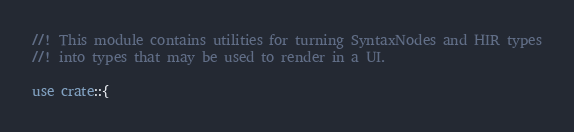<code> <loc_0><loc_0><loc_500><loc_500><_Rust_>//! This module contains utilities for turning SyntaxNodes and HIR types
//! into types that may be used to render in a UI.

use crate::{</code> 